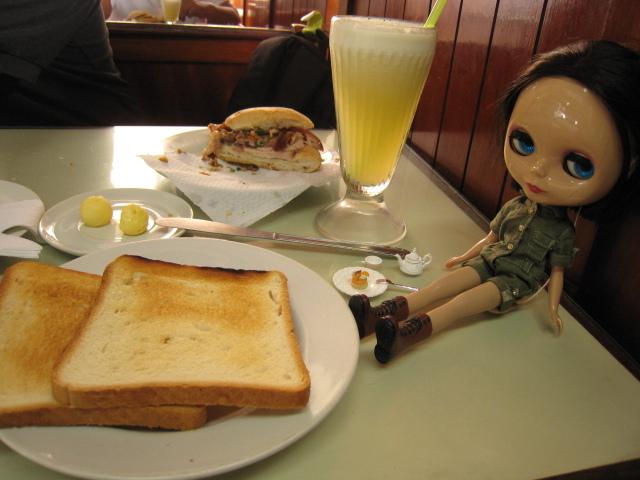Who does the doll belong to?
Concise answer only. Girl. Where are the toast?
Give a very brief answer. Plate. How many slices of bread are there?
Keep it brief. 2. 